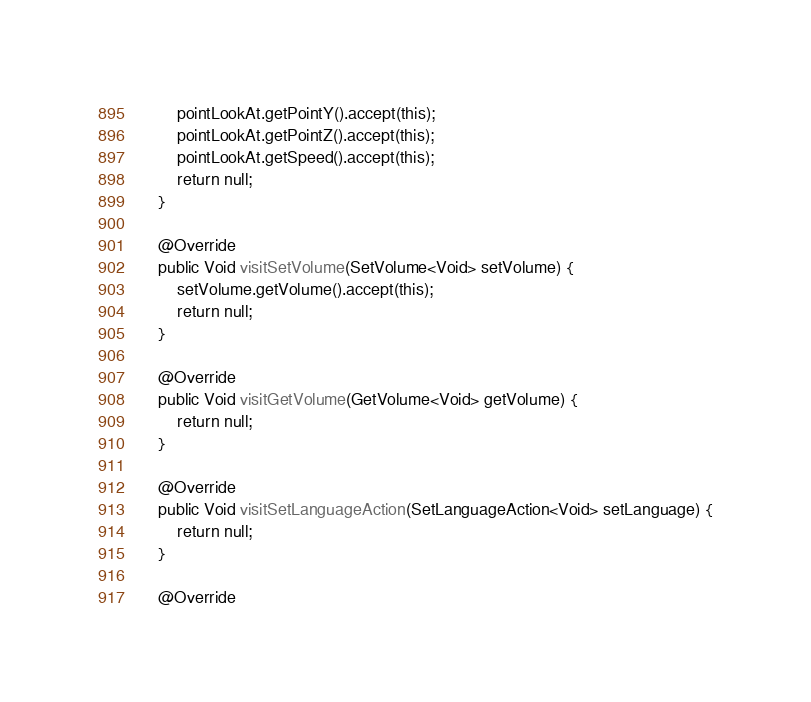<code> <loc_0><loc_0><loc_500><loc_500><_Java_>        pointLookAt.getPointY().accept(this);
        pointLookAt.getPointZ().accept(this);
        pointLookAt.getSpeed().accept(this);
        return null;
    }

    @Override
    public Void visitSetVolume(SetVolume<Void> setVolume) {
        setVolume.getVolume().accept(this);
        return null;
    }

    @Override
    public Void visitGetVolume(GetVolume<Void> getVolume) {
        return null;
    }

    @Override
    public Void visitSetLanguageAction(SetLanguageAction<Void> setLanguage) {
        return null;
    }

    @Override</code> 